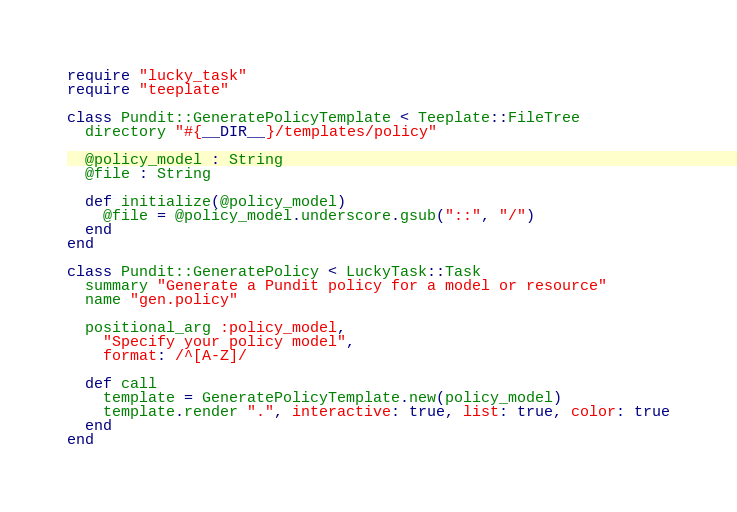<code> <loc_0><loc_0><loc_500><loc_500><_Crystal_>require "lucky_task"
require "teeplate"

class Pundit::GeneratePolicyTemplate < Teeplate::FileTree
  directory "#{__DIR__}/templates/policy"

  @policy_model : String
  @file : String

  def initialize(@policy_model)
    @file = @policy_model.underscore.gsub("::", "/")
  end
end

class Pundit::GeneratePolicy < LuckyTask::Task
  summary "Generate a Pundit policy for a model or resource"
  name "gen.policy"

  positional_arg :policy_model,
    "Specify your policy model",
    format: /^[A-Z]/

  def call
    template = GeneratePolicyTemplate.new(policy_model)
    template.render ".", interactive: true, list: true, color: true
  end
end
</code> 